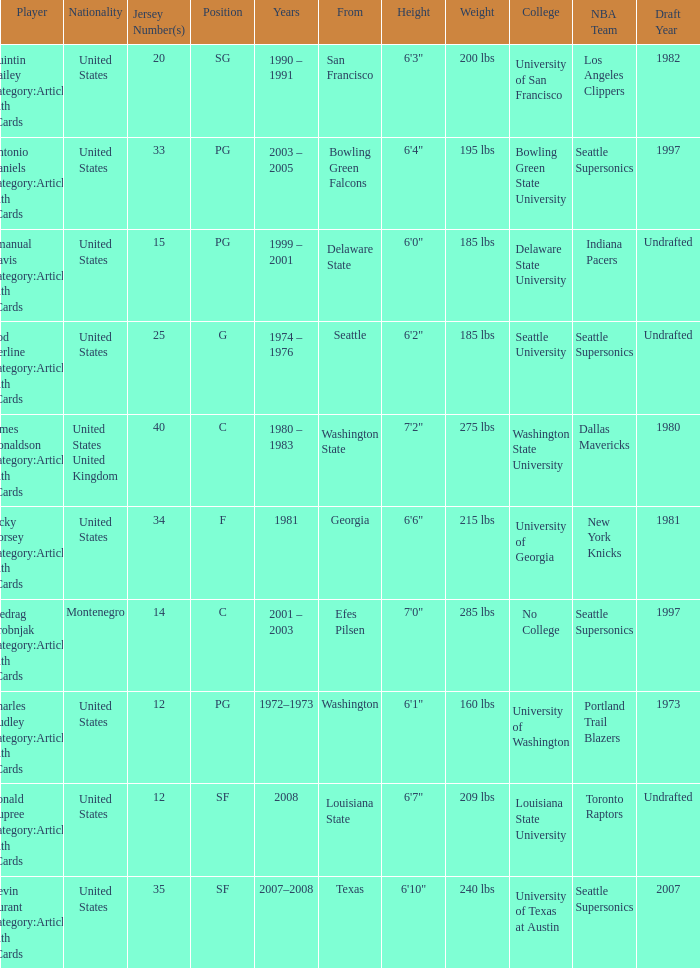What college was the player with the jersey number of 34 from? Georgia. 